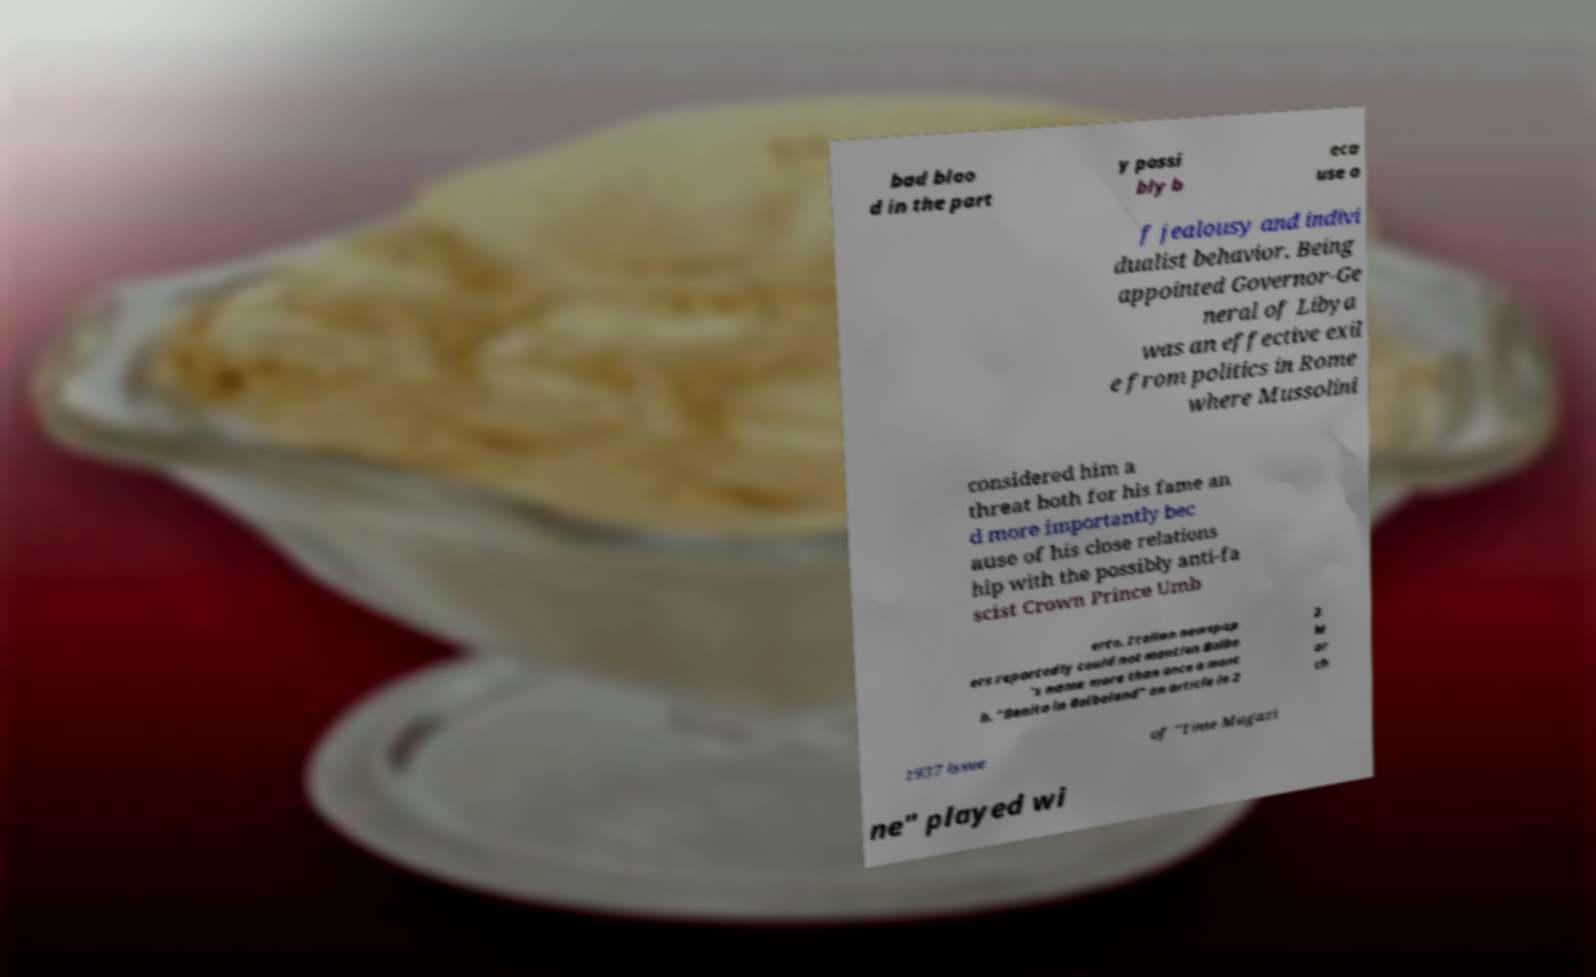What messages or text are displayed in this image? I need them in a readable, typed format. bad bloo d in the part y possi bly b eca use o f jealousy and indivi dualist behavior. Being appointed Governor-Ge neral of Libya was an effective exil e from politics in Rome where Mussolini considered him a threat both for his fame an d more importantly bec ause of his close relations hip with the possibly anti-fa scist Crown Prince Umb erto. Italian newspap ers reportedly could not mention Balbo 's name more than once a mont h. "Benito in Balboland" an article in 2 2 M ar ch 1937 issue of "Time Magazi ne" played wi 